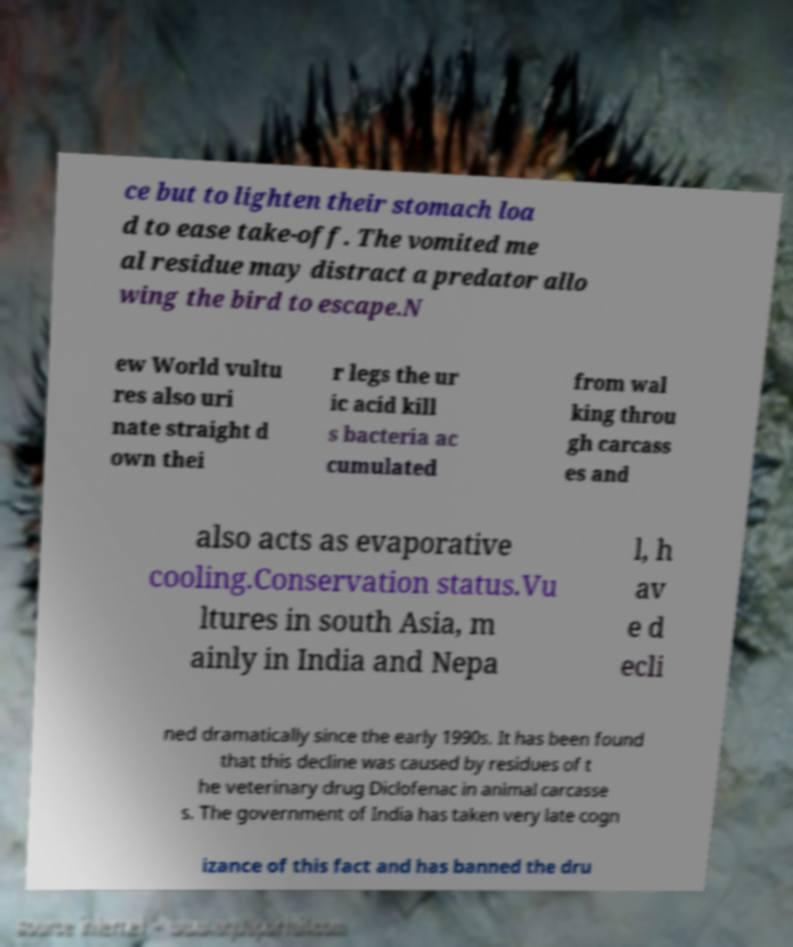Could you assist in decoding the text presented in this image and type it out clearly? ce but to lighten their stomach loa d to ease take-off. The vomited me al residue may distract a predator allo wing the bird to escape.N ew World vultu res also uri nate straight d own thei r legs the ur ic acid kill s bacteria ac cumulated from wal king throu gh carcass es and also acts as evaporative cooling.Conservation status.Vu ltures in south Asia, m ainly in India and Nepa l, h av e d ecli ned dramatically since the early 1990s. It has been found that this decline was caused by residues of t he veterinary drug Diclofenac in animal carcasse s. The government of India has taken very late cogn izance of this fact and has banned the dru 